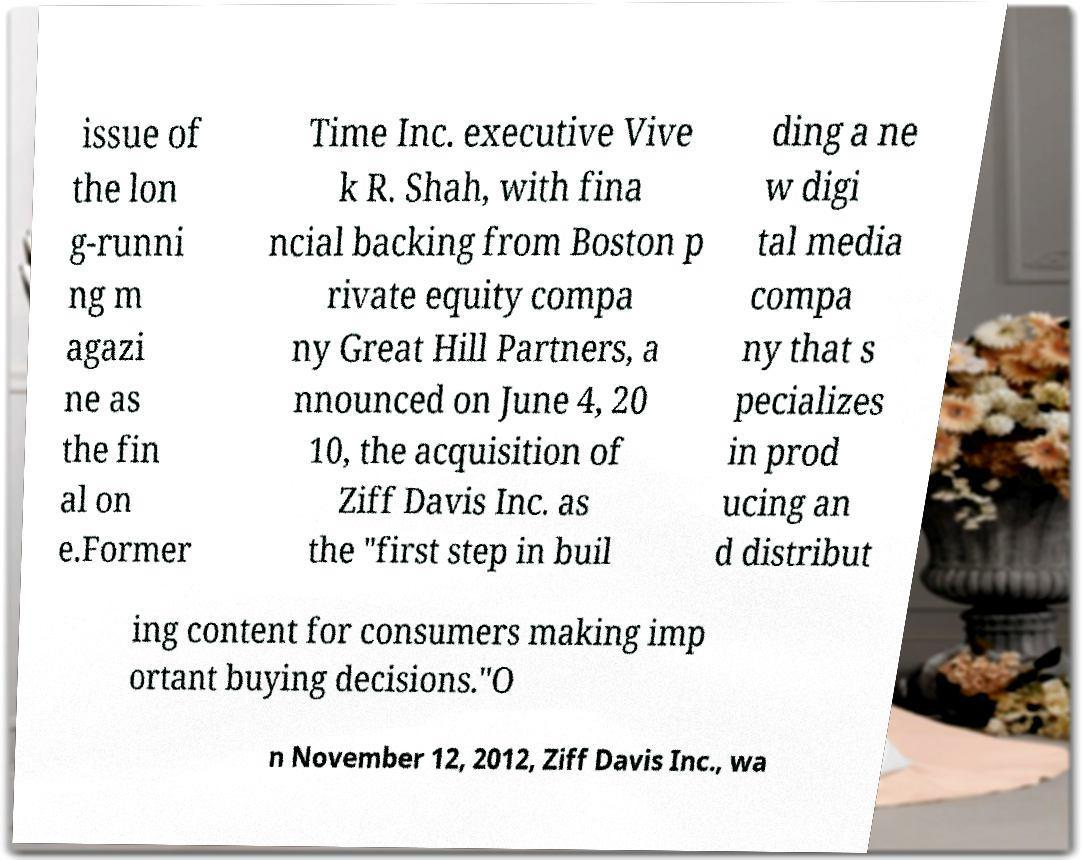What messages or text are displayed in this image? I need them in a readable, typed format. issue of the lon g-runni ng m agazi ne as the fin al on e.Former Time Inc. executive Vive k R. Shah, with fina ncial backing from Boston p rivate equity compa ny Great Hill Partners, a nnounced on June 4, 20 10, the acquisition of Ziff Davis Inc. as the "first step in buil ding a ne w digi tal media compa ny that s pecializes in prod ucing an d distribut ing content for consumers making imp ortant buying decisions."O n November 12, 2012, Ziff Davis Inc., wa 